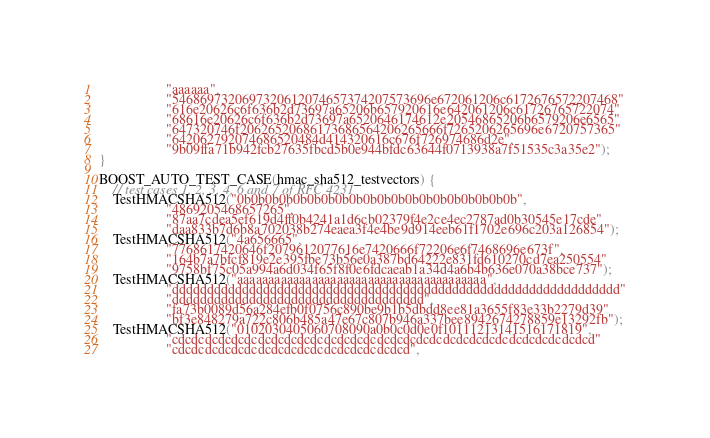Convert code to text. <code><loc_0><loc_0><loc_500><loc_500><_C++_>                   "aaaaaa",
                   "5468697320697320612074657374207573696e672061206c6172676572207468"
                   "616e20626c6f636b2d73697a65206b657920616e642061206c61726765722074"
                   "68616e20626c6f636b2d73697a6520646174612e20546865206b6579206e6565"
                   "647320746f20626520686173686564206265666f7265206265696e6720757365"
                   "642062792074686520484d414320616c676f726974686d2e",
                   "9b09ffa71b942fcb27635fbcd5b0e944bfdc63644f0713938a7f51535c3a35e2");
}

BOOST_AUTO_TEST_CASE(hmac_sha512_testvectors) {
    // test cases 1, 2, 3, 4, 6 and 7 of RFC 4231
    TestHMACSHA512("0b0b0b0b0b0b0b0b0b0b0b0b0b0b0b0b0b0b0b0b",
                   "4869205468657265",
                   "87aa7cdea5ef619d4ff0b4241a1d6cb02379f4e2ce4ec2787ad0b30545e17cde"
                   "daa833b7d6b8a702038b274eaea3f4e4be9d914eeb61f1702e696c203a126854");
    TestHMACSHA512("4a656665",
                   "7768617420646f2079612077616e7420666f72206e6f7468696e673f",
                   "164b7a7bfcf819e2e395fbe73b56e0a387bd64222e831fd610270cd7ea250554"
                   "9758bf75c05a994a6d034f65f8f0e6fdcaeab1a34d4a6b4b636e070a38bce737");
    TestHMACSHA512("aaaaaaaaaaaaaaaaaaaaaaaaaaaaaaaaaaaaaaaa",
                   "dddddddddddddddddddddddddddddddddddddddddddddddddddddddddddddddd"
                   "dddddddddddddddddddddddddddddddddddd",
                   "fa73b0089d56a284efb0f0756c890be9b1b5dbdd8ee81a3655f83e33b2279d39"
                   "bf3e848279a722c806b485a47e67c807b946a337bee8942674278859e13292fb");
    TestHMACSHA512("0102030405060708090a0b0c0d0e0f10111213141516171819",
                   "cdcdcdcdcdcdcdcdcdcdcdcdcdcdcdcdcdcdcdcdcdcdcdcdcdcdcdcdcdcdcdcd"
                   "cdcdcdcdcdcdcdcdcdcdcdcdcdcdcdcdcdcd",</code> 